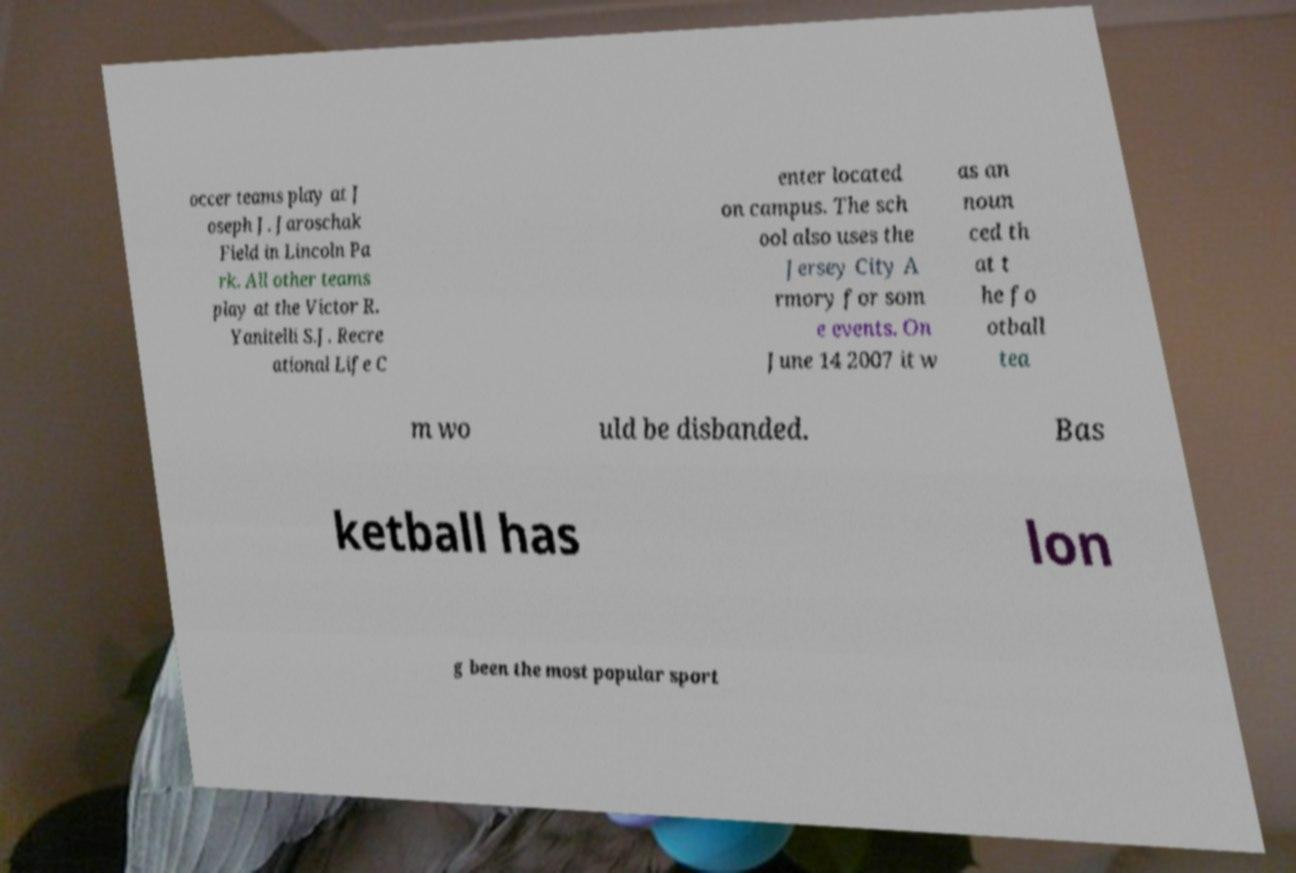Could you assist in decoding the text presented in this image and type it out clearly? occer teams play at J oseph J. Jaroschak Field in Lincoln Pa rk. All other teams play at the Victor R. Yanitelli S.J. Recre ational Life C enter located on campus. The sch ool also uses the Jersey City A rmory for som e events. On June 14 2007 it w as an noun ced th at t he fo otball tea m wo uld be disbanded. Bas ketball has lon g been the most popular sport 